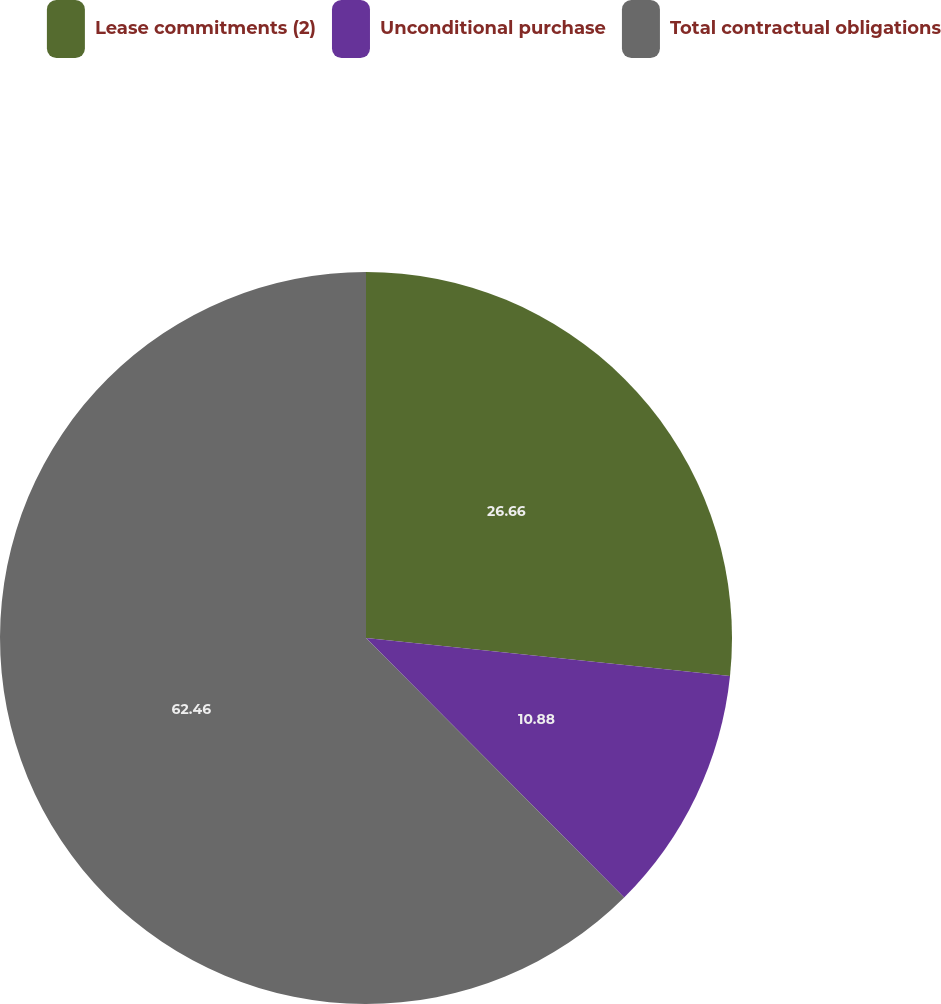Convert chart. <chart><loc_0><loc_0><loc_500><loc_500><pie_chart><fcel>Lease commitments (2)<fcel>Unconditional purchase<fcel>Total contractual obligations<nl><fcel>26.66%<fcel>10.88%<fcel>62.46%<nl></chart> 